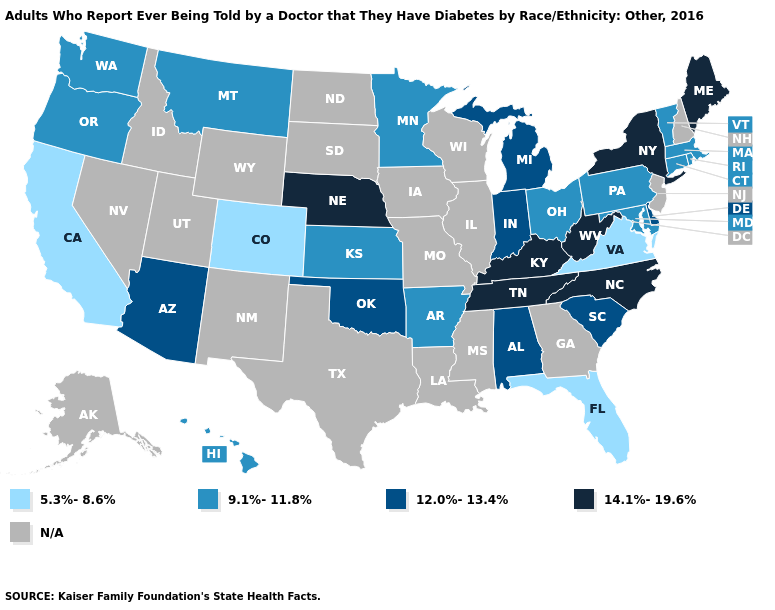What is the highest value in states that border North Dakota?
Keep it brief. 9.1%-11.8%. What is the value of Montana?
Be succinct. 9.1%-11.8%. What is the value of Georgia?
Keep it brief. N/A. What is the highest value in the USA?
Give a very brief answer. 14.1%-19.6%. What is the value of Vermont?
Give a very brief answer. 9.1%-11.8%. Among the states that border Massachusetts , which have the highest value?
Give a very brief answer. New York. What is the value of North Carolina?
Answer briefly. 14.1%-19.6%. What is the lowest value in states that border South Carolina?
Keep it brief. 14.1%-19.6%. Among the states that border Utah , which have the highest value?
Concise answer only. Arizona. Is the legend a continuous bar?
Answer briefly. No. Does Ohio have the lowest value in the USA?
Short answer required. No. Among the states that border Ohio , which have the lowest value?
Answer briefly. Pennsylvania. 